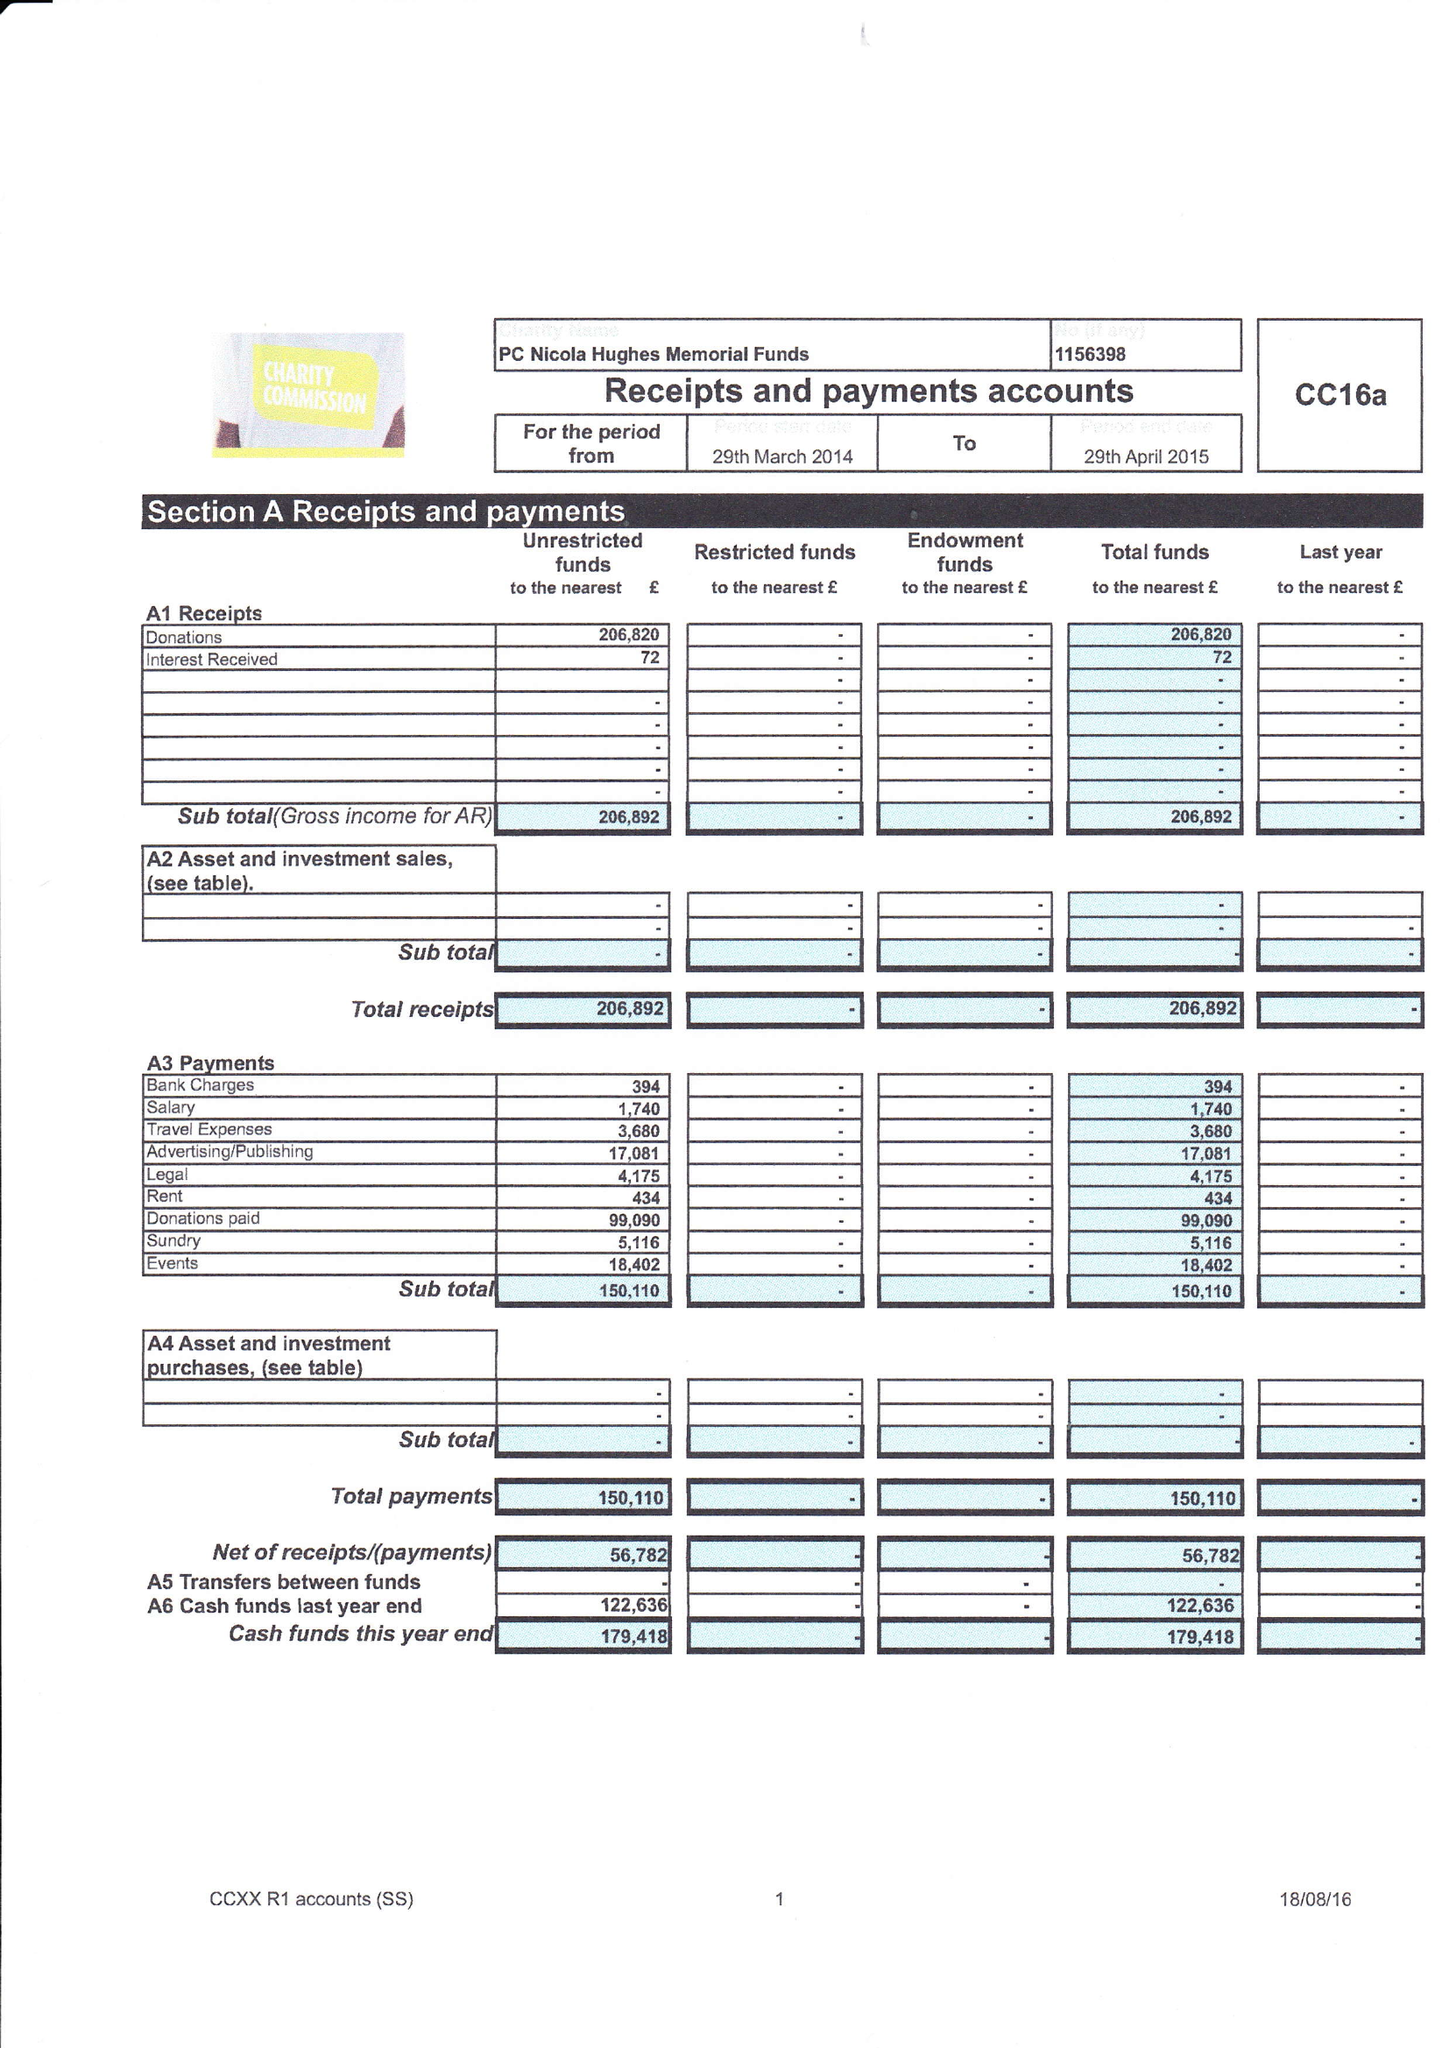What is the value for the income_annually_in_british_pounds?
Answer the question using a single word or phrase. 206892.00 